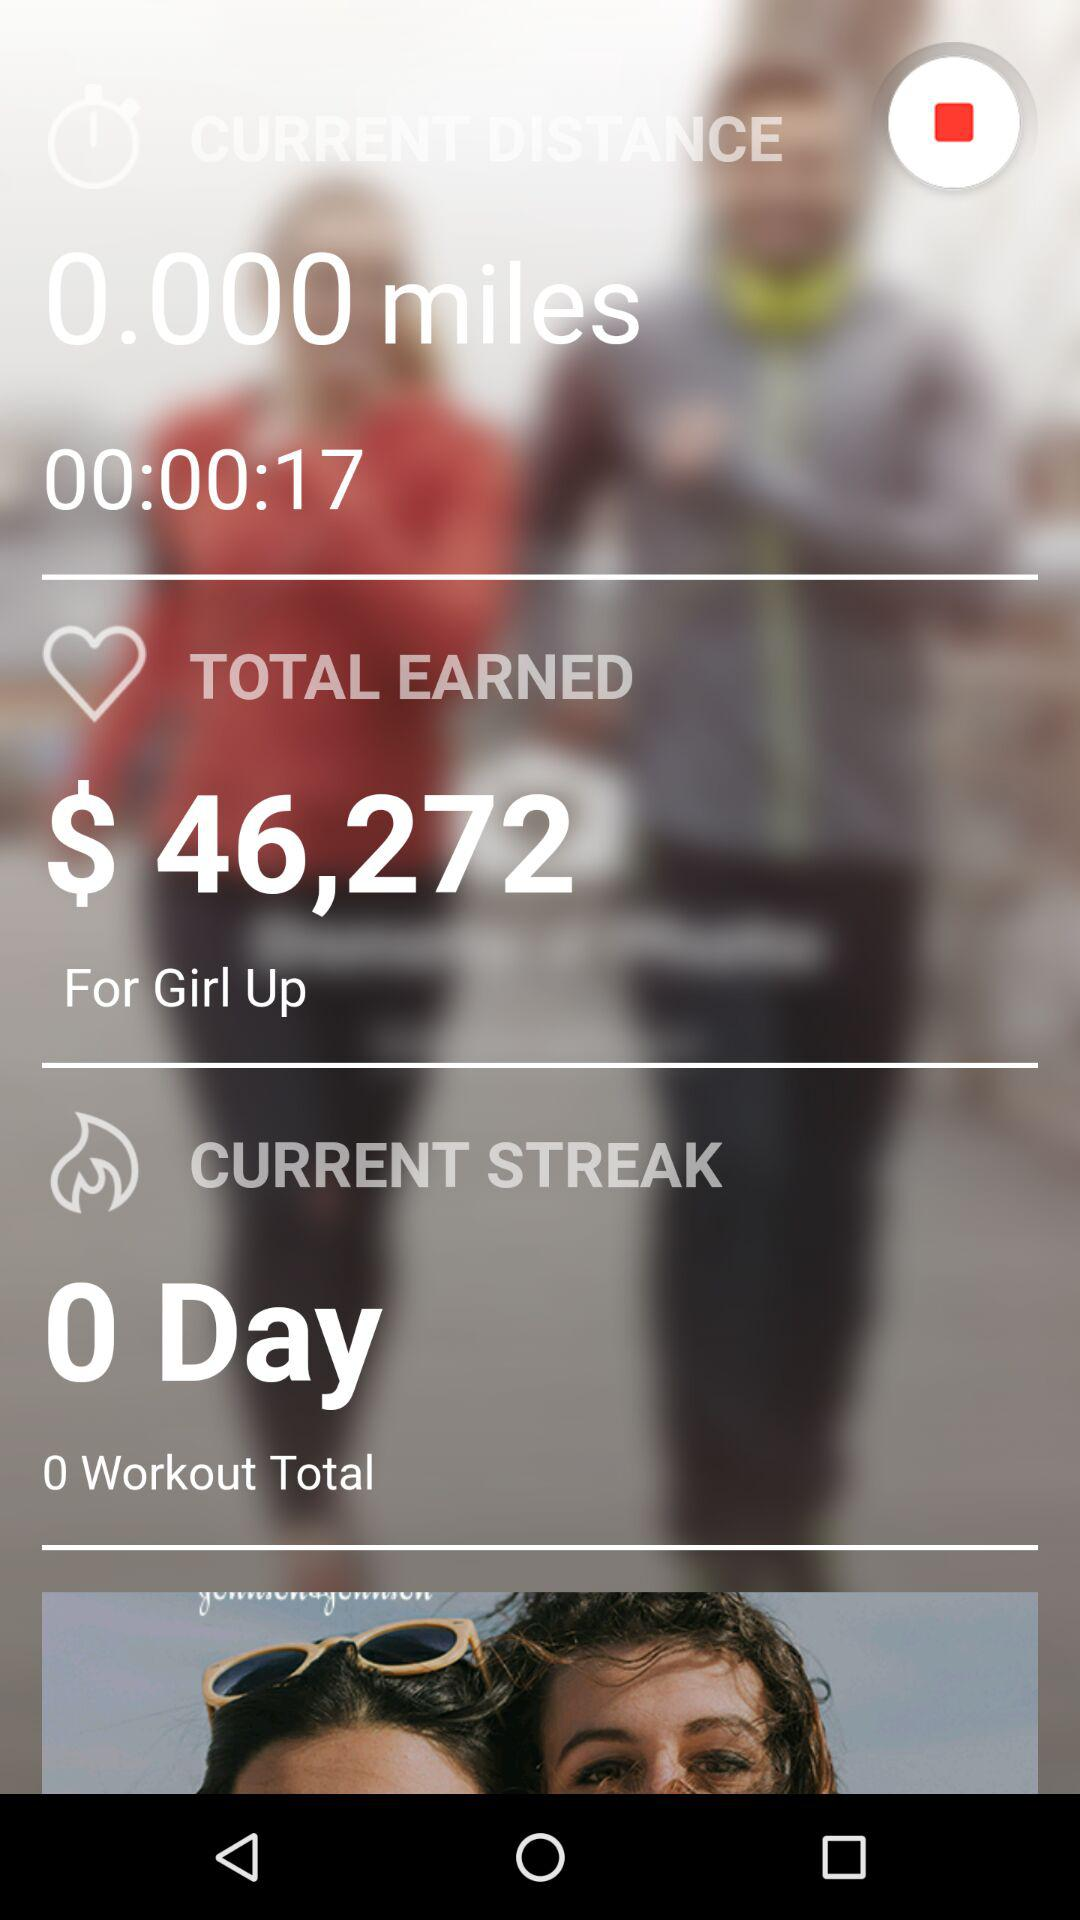What is the username?
When the provided information is insufficient, respond with <no answer>. <no answer> 